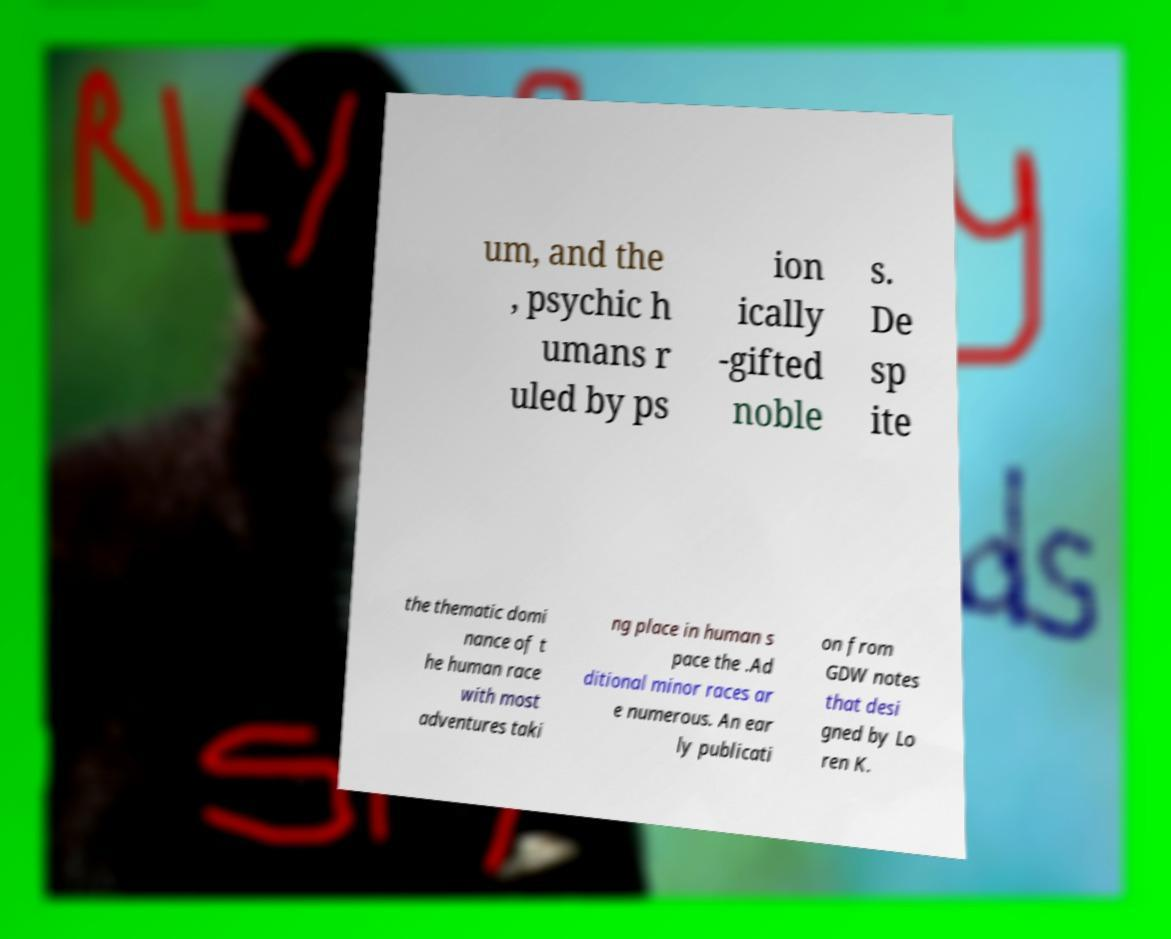For documentation purposes, I need the text within this image transcribed. Could you provide that? um, and the , psychic h umans r uled by ps ion ically -gifted noble s. De sp ite the thematic domi nance of t he human race with most adventures taki ng place in human s pace the .Ad ditional minor races ar e numerous. An ear ly publicati on from GDW notes that desi gned by Lo ren K. 